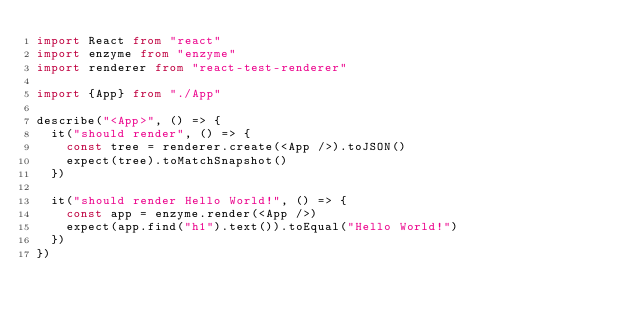<code> <loc_0><loc_0><loc_500><loc_500><_TypeScript_>import React from "react"
import enzyme from "enzyme"
import renderer from "react-test-renderer"

import {App} from "./App"

describe("<App>", () => {
  it("should render", () => {
    const tree = renderer.create(<App />).toJSON()
    expect(tree).toMatchSnapshot()
  })

  it("should render Hello World!", () => {
    const app = enzyme.render(<App />)
    expect(app.find("h1").text()).toEqual("Hello World!")
  })
})
</code> 